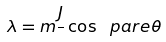<formula> <loc_0><loc_0><loc_500><loc_500>\lambda = \i m \frac { J } { } \cos \ p a r e { \theta }</formula> 